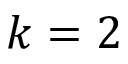Convert formula to latex. <formula><loc_0><loc_0><loc_500><loc_500>k = 2</formula> 